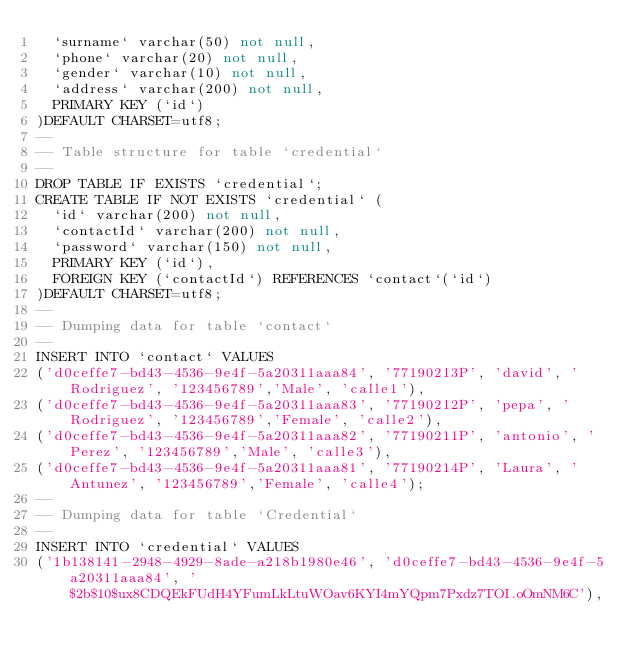<code> <loc_0><loc_0><loc_500><loc_500><_SQL_>  `surname` varchar(50) not null,
  `phone` varchar(20) not null,
  `gender` varchar(10) not null,
  `address` varchar(200) not null,
  PRIMARY KEY (`id`)
)DEFAULT CHARSET=utf8;
--
-- Table structure for table `credential`
--
DROP TABLE IF EXISTS `credential`;
CREATE TABLE IF NOT EXISTS `credential` (
  `id` varchar(200) not null,
  `contactId` varchar(200) not null,
  `password` varchar(150) not null,
  PRIMARY KEY (`id`),
  FOREIGN KEY (`contactId`) REFERENCES `contact`(`id`)
)DEFAULT CHARSET=utf8;
--
-- Dumping data for table `contact`
--
INSERT INTO `contact` VALUES
('d0ceffe7-bd43-4536-9e4f-5a20311aaa84', '77190213P', 'david', 'Rodriguez', '123456789','Male', 'calle1'),
('d0ceffe7-bd43-4536-9e4f-5a20311aaa83', '77190212P', 'pepa', 'Rodriguez', '123456789','Female', 'calle2'),
('d0ceffe7-bd43-4536-9e4f-5a20311aaa82', '77190211P', 'antonio', 'Perez', '123456789','Male', 'calle3'),
('d0ceffe7-bd43-4536-9e4f-5a20311aaa81', '77190214P', 'Laura', 'Antunez', '123456789','Female', 'calle4');
--
-- Dumping data for table `Credential`
--
INSERT INTO `credential` VALUES
('1b138141-2948-4929-8ade-a218b1980e46', 'd0ceffe7-bd43-4536-9e4f-5a20311aaa84', '$2b$10$ux8CDQEkFUdH4YFumLkLtuWOav6KYI4mYQpm7Pxdz7TOI.oOmNM6C'),</code> 